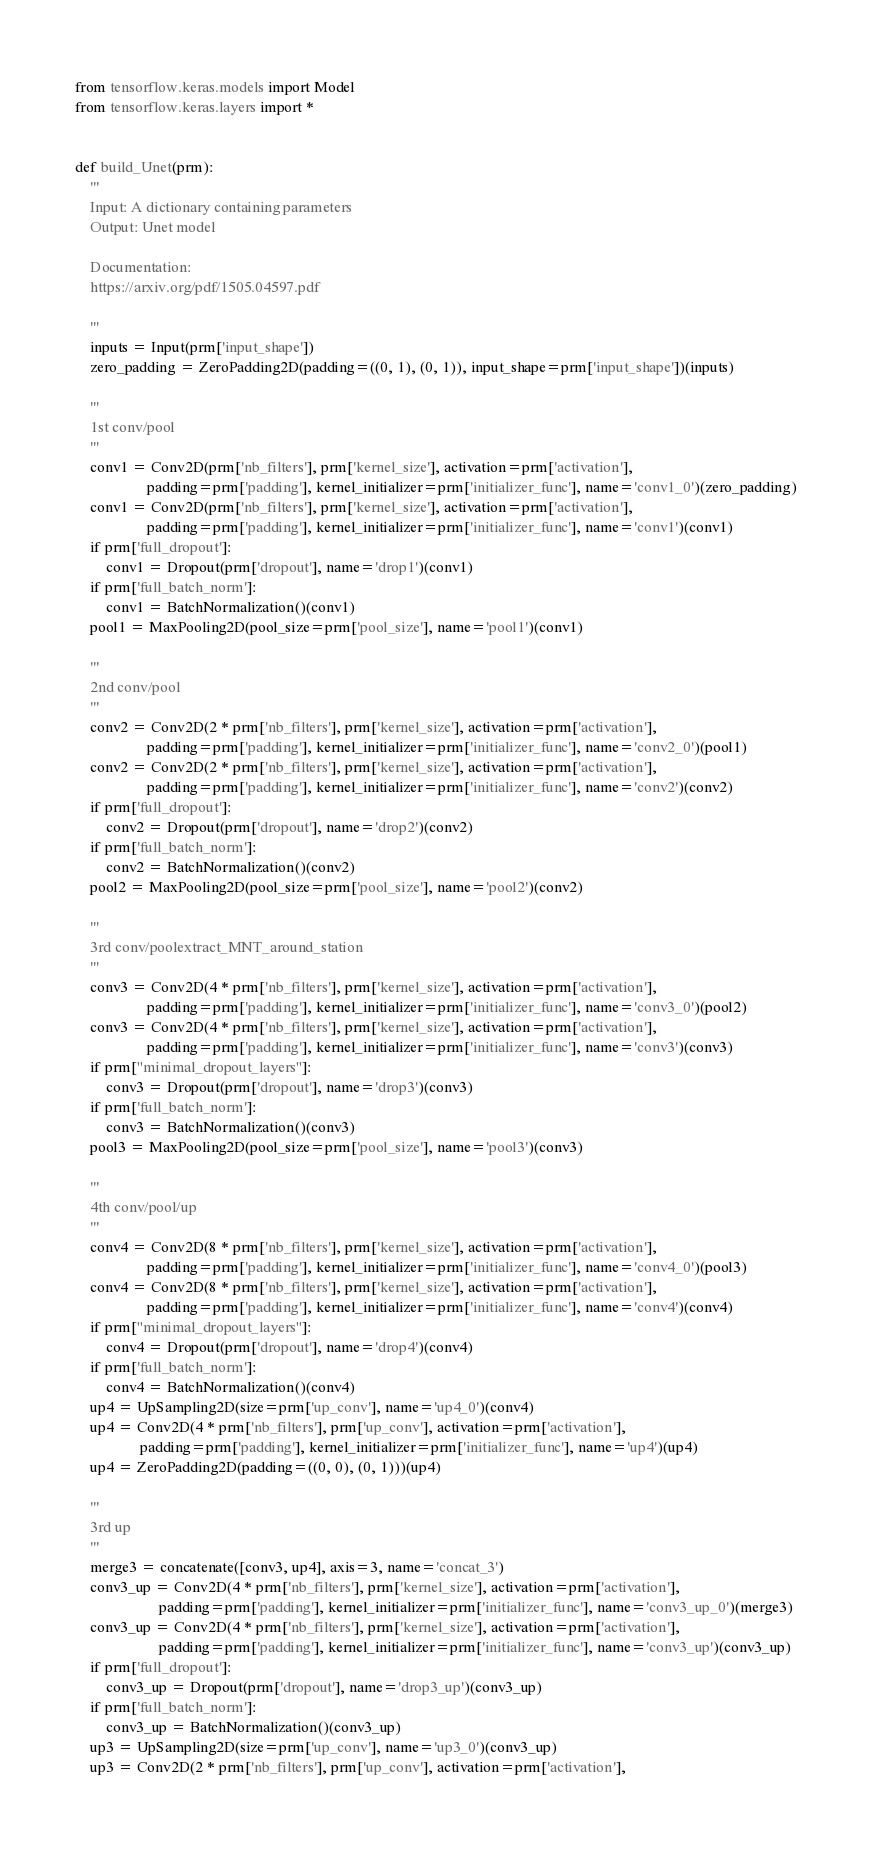Convert code to text. <code><loc_0><loc_0><loc_500><loc_500><_Python_>from tensorflow.keras.models import Model
from tensorflow.keras.layers import *


def build_Unet(prm):
    '''
    Input: A dictionary containing parameters
    Output: Unet model
    
    Documentation:
    https://arxiv.org/pdf/1505.04597.pdf
    
    '''
    inputs = Input(prm['input_shape'])
    zero_padding = ZeroPadding2D(padding=((0, 1), (0, 1)), input_shape=prm['input_shape'])(inputs)

    '''
    1st conv/pool
    '''
    conv1 = Conv2D(prm['nb_filters'], prm['kernel_size'], activation=prm['activation'],
                   padding=prm['padding'], kernel_initializer=prm['initializer_func'], name='conv1_0')(zero_padding)
    conv1 = Conv2D(prm['nb_filters'], prm['kernel_size'], activation=prm['activation'],
                   padding=prm['padding'], kernel_initializer=prm['initializer_func'], name='conv1')(conv1)
    if prm['full_dropout']:
        conv1 = Dropout(prm['dropout'], name='drop1')(conv1)
    if prm['full_batch_norm']:
        conv1 = BatchNormalization()(conv1)
    pool1 = MaxPooling2D(pool_size=prm['pool_size'], name='pool1')(conv1)

    '''
    2nd conv/pool
    '''
    conv2 = Conv2D(2 * prm['nb_filters'], prm['kernel_size'], activation=prm['activation'],
                   padding=prm['padding'], kernel_initializer=prm['initializer_func'], name='conv2_0')(pool1)
    conv2 = Conv2D(2 * prm['nb_filters'], prm['kernel_size'], activation=prm['activation'],
                   padding=prm['padding'], kernel_initializer=prm['initializer_func'], name='conv2')(conv2)
    if prm['full_dropout']:
        conv2 = Dropout(prm['dropout'], name='drop2')(conv2)
    if prm['full_batch_norm']:
        conv2 = BatchNormalization()(conv2)
    pool2 = MaxPooling2D(pool_size=prm['pool_size'], name='pool2')(conv2)

    '''
    3rd conv/poolextract_MNT_around_station
    '''
    conv3 = Conv2D(4 * prm['nb_filters'], prm['kernel_size'], activation=prm['activation'],
                   padding=prm['padding'], kernel_initializer=prm['initializer_func'], name='conv3_0')(pool2)
    conv3 = Conv2D(4 * prm['nb_filters'], prm['kernel_size'], activation=prm['activation'],
                   padding=prm['padding'], kernel_initializer=prm['initializer_func'], name='conv3')(conv3)
    if prm["minimal_dropout_layers"]:
        conv3 = Dropout(prm['dropout'], name='drop3')(conv3)
    if prm['full_batch_norm']:
        conv3 = BatchNormalization()(conv3)
    pool3 = MaxPooling2D(pool_size=prm['pool_size'], name='pool3')(conv3)

    '''
    4th conv/pool/up
    '''
    conv4 = Conv2D(8 * prm['nb_filters'], prm['kernel_size'], activation=prm['activation'],
                   padding=prm['padding'], kernel_initializer=prm['initializer_func'], name='conv4_0')(pool3)
    conv4 = Conv2D(8 * prm['nb_filters'], prm['kernel_size'], activation=prm['activation'],
                   padding=prm['padding'], kernel_initializer=prm['initializer_func'], name='conv4')(conv4)
    if prm["minimal_dropout_layers"]:
        conv4 = Dropout(prm['dropout'], name='drop4')(conv4)
    if prm['full_batch_norm']:
        conv4 = BatchNormalization()(conv4)
    up4 = UpSampling2D(size=prm['up_conv'], name='up4_0')(conv4)
    up4 = Conv2D(4 * prm['nb_filters'], prm['up_conv'], activation=prm['activation'],
                 padding=prm['padding'], kernel_initializer=prm['initializer_func'], name='up4')(up4)
    up4 = ZeroPadding2D(padding=((0, 0), (0, 1)))(up4)

    '''
    3rd up
    '''
    merge3 = concatenate([conv3, up4], axis=3, name='concat_3')
    conv3_up = Conv2D(4 * prm['nb_filters'], prm['kernel_size'], activation=prm['activation'],
                      padding=prm['padding'], kernel_initializer=prm['initializer_func'], name='conv3_up_0')(merge3)
    conv3_up = Conv2D(4 * prm['nb_filters'], prm['kernel_size'], activation=prm['activation'],
                      padding=prm['padding'], kernel_initializer=prm['initializer_func'], name='conv3_up')(conv3_up)
    if prm['full_dropout']:
        conv3_up = Dropout(prm['dropout'], name='drop3_up')(conv3_up)
    if prm['full_batch_norm']:
        conv3_up = BatchNormalization()(conv3_up)
    up3 = UpSampling2D(size=prm['up_conv'], name='up3_0')(conv3_up)
    up3 = Conv2D(2 * prm['nb_filters'], prm['up_conv'], activation=prm['activation'],</code> 